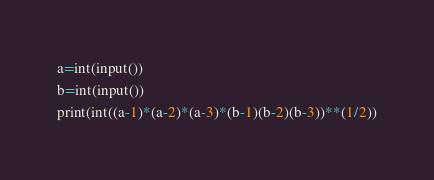Convert code to text. <code><loc_0><loc_0><loc_500><loc_500><_Python_>a=int(input())
b=int(input())
print(int((a-1)*(a-2)*(a-3)*(b-1)(b-2)(b-3))**(1/2))</code> 